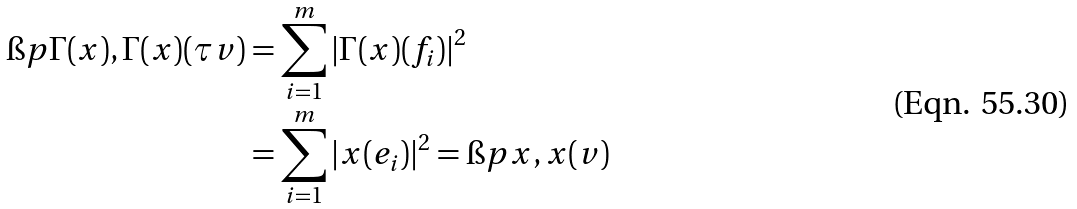Convert formula to latex. <formula><loc_0><loc_0><loc_500><loc_500>\i p { \Gamma ( x ) , \Gamma ( x ) } ( \tau v ) & = \sum _ { i = 1 } ^ { m } | \Gamma ( x ) ( f _ { i } ) | ^ { 2 } \\ & = \sum _ { i = 1 } ^ { m } | x ( e _ { i } ) | ^ { 2 } = \i p { x , x } ( v )</formula> 